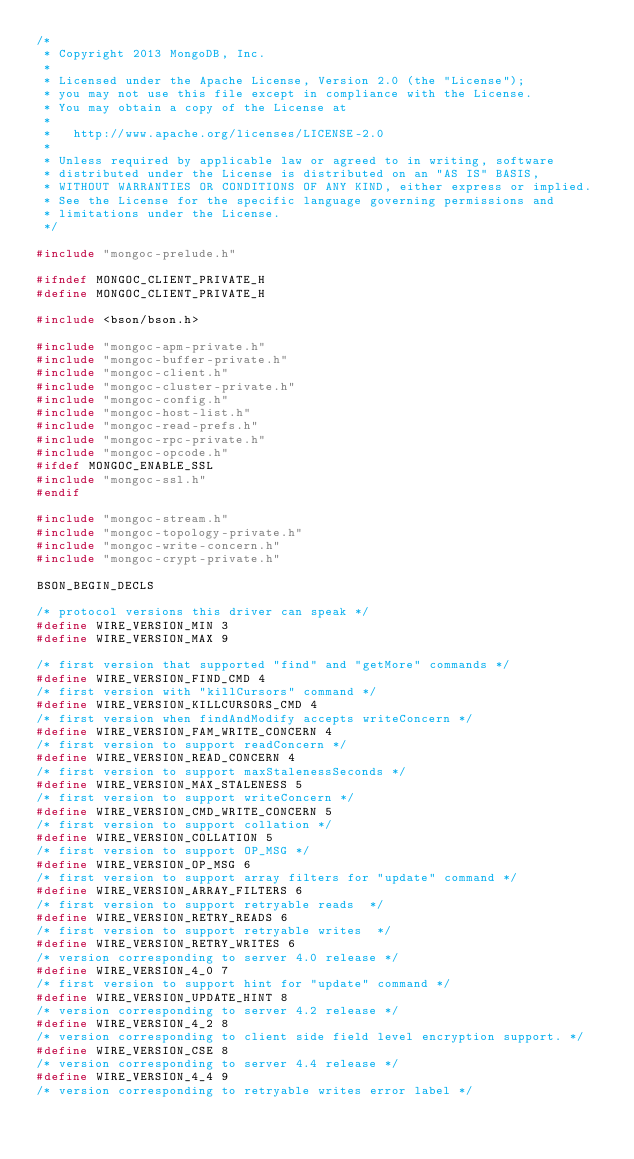<code> <loc_0><loc_0><loc_500><loc_500><_C_>/*
 * Copyright 2013 MongoDB, Inc.
 *
 * Licensed under the Apache License, Version 2.0 (the "License");
 * you may not use this file except in compliance with the License.
 * You may obtain a copy of the License at
 *
 *   http://www.apache.org/licenses/LICENSE-2.0
 *
 * Unless required by applicable law or agreed to in writing, software
 * distributed under the License is distributed on an "AS IS" BASIS,
 * WITHOUT WARRANTIES OR CONDITIONS OF ANY KIND, either express or implied.
 * See the License for the specific language governing permissions and
 * limitations under the License.
 */

#include "mongoc-prelude.h"

#ifndef MONGOC_CLIENT_PRIVATE_H
#define MONGOC_CLIENT_PRIVATE_H

#include <bson/bson.h>

#include "mongoc-apm-private.h"
#include "mongoc-buffer-private.h"
#include "mongoc-client.h"
#include "mongoc-cluster-private.h"
#include "mongoc-config.h"
#include "mongoc-host-list.h"
#include "mongoc-read-prefs.h"
#include "mongoc-rpc-private.h"
#include "mongoc-opcode.h"
#ifdef MONGOC_ENABLE_SSL
#include "mongoc-ssl.h"
#endif

#include "mongoc-stream.h"
#include "mongoc-topology-private.h"
#include "mongoc-write-concern.h"
#include "mongoc-crypt-private.h"

BSON_BEGIN_DECLS

/* protocol versions this driver can speak */
#define WIRE_VERSION_MIN 3
#define WIRE_VERSION_MAX 9

/* first version that supported "find" and "getMore" commands */
#define WIRE_VERSION_FIND_CMD 4
/* first version with "killCursors" command */
#define WIRE_VERSION_KILLCURSORS_CMD 4
/* first version when findAndModify accepts writeConcern */
#define WIRE_VERSION_FAM_WRITE_CONCERN 4
/* first version to support readConcern */
#define WIRE_VERSION_READ_CONCERN 4
/* first version to support maxStalenessSeconds */
#define WIRE_VERSION_MAX_STALENESS 5
/* first version to support writeConcern */
#define WIRE_VERSION_CMD_WRITE_CONCERN 5
/* first version to support collation */
#define WIRE_VERSION_COLLATION 5
/* first version to support OP_MSG */
#define WIRE_VERSION_OP_MSG 6
/* first version to support array filters for "update" command */
#define WIRE_VERSION_ARRAY_FILTERS 6
/* first version to support retryable reads  */
#define WIRE_VERSION_RETRY_READS 6
/* first version to support retryable writes  */
#define WIRE_VERSION_RETRY_WRITES 6
/* version corresponding to server 4.0 release */
#define WIRE_VERSION_4_0 7
/* first version to support hint for "update" command */
#define WIRE_VERSION_UPDATE_HINT 8
/* version corresponding to server 4.2 release */
#define WIRE_VERSION_4_2 8
/* version corresponding to client side field level encryption support. */
#define WIRE_VERSION_CSE 8
/* version corresponding to server 4.4 release */
#define WIRE_VERSION_4_4 9
/* version corresponding to retryable writes error label */</code> 